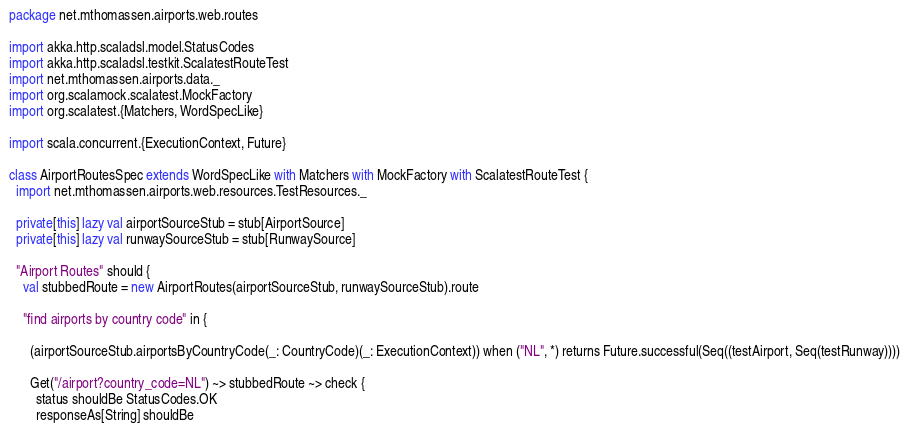<code> <loc_0><loc_0><loc_500><loc_500><_Scala_>package net.mthomassen.airports.web.routes

import akka.http.scaladsl.model.StatusCodes
import akka.http.scaladsl.testkit.ScalatestRouteTest
import net.mthomassen.airports.data._
import org.scalamock.scalatest.MockFactory
import org.scalatest.{Matchers, WordSpecLike}

import scala.concurrent.{ExecutionContext, Future}

class AirportRoutesSpec extends WordSpecLike with Matchers with MockFactory with ScalatestRouteTest {
  import net.mthomassen.airports.web.resources.TestResources._

  private[this] lazy val airportSourceStub = stub[AirportSource]
  private[this] lazy val runwaySourceStub = stub[RunwaySource]

  "Airport Routes" should {
    val stubbedRoute = new AirportRoutes(airportSourceStub, runwaySourceStub).route

    "find airports by country code" in {

      (airportSourceStub.airportsByCountryCode(_: CountryCode)(_: ExecutionContext)) when ("NL", *) returns Future.successful(Seq((testAirport, Seq(testRunway))))

      Get("/airport?country_code=NL") ~> stubbedRoute ~> check {
        status shouldBe StatusCodes.OK
        responseAs[String] shouldBe</code> 